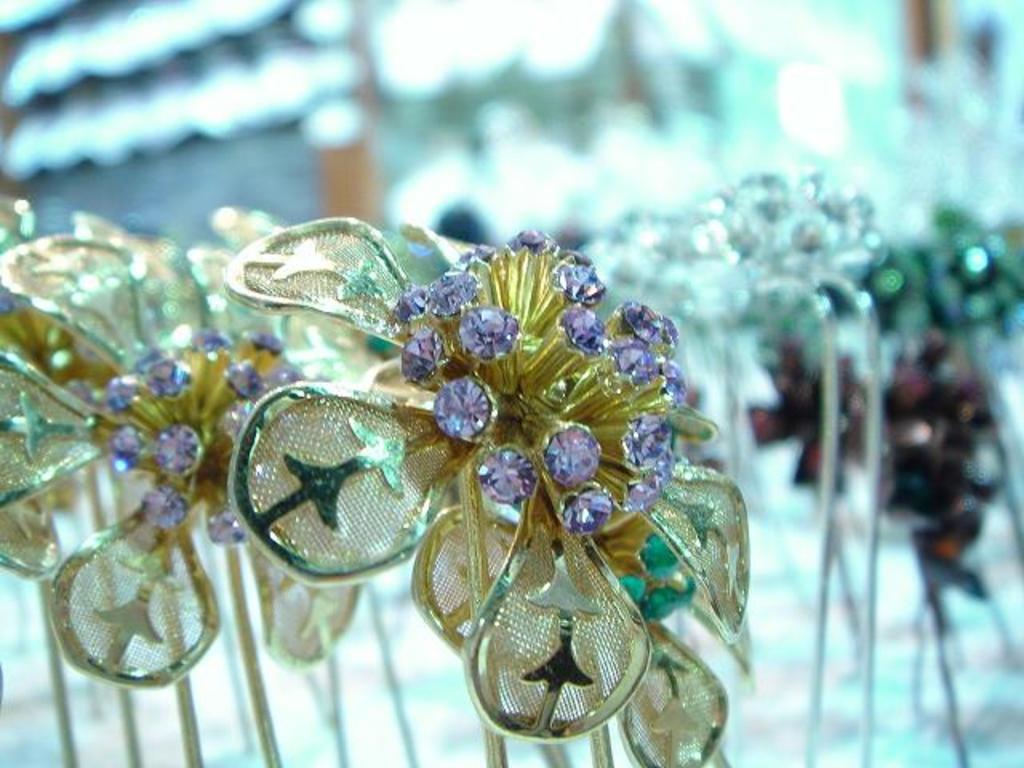Please provide a concise description of this image. Here we can see ornaments. Background it is blur. 